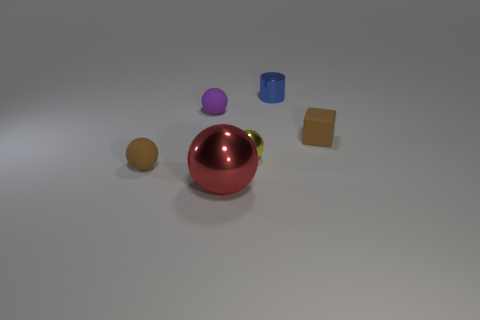Is the cylinder the same size as the red shiny object?
Offer a very short reply. No. The brown thing that is on the right side of the tiny rubber thing behind the tiny brown rubber thing that is behind the yellow ball is made of what material?
Your response must be concise. Rubber. Is the number of big objects behind the purple thing the same as the number of large blue blocks?
Ensure brevity in your answer.  Yes. Are there any other things that are the same size as the red object?
Make the answer very short. No. How many objects are either tiny cyan rubber cubes or small matte things?
Provide a short and direct response. 3. What shape is the tiny brown object that is made of the same material as the small brown ball?
Ensure brevity in your answer.  Cube. What is the size of the matte ball that is in front of the purple sphere that is in front of the small blue cylinder?
Provide a short and direct response. Small. What number of tiny things are either metal cylinders or brown cubes?
Provide a succinct answer. 2. How many other objects are there of the same color as the small matte cube?
Keep it short and to the point. 1. Do the matte thing to the right of the small blue metal cylinder and the sphere that is in front of the brown ball have the same size?
Your response must be concise. No. 